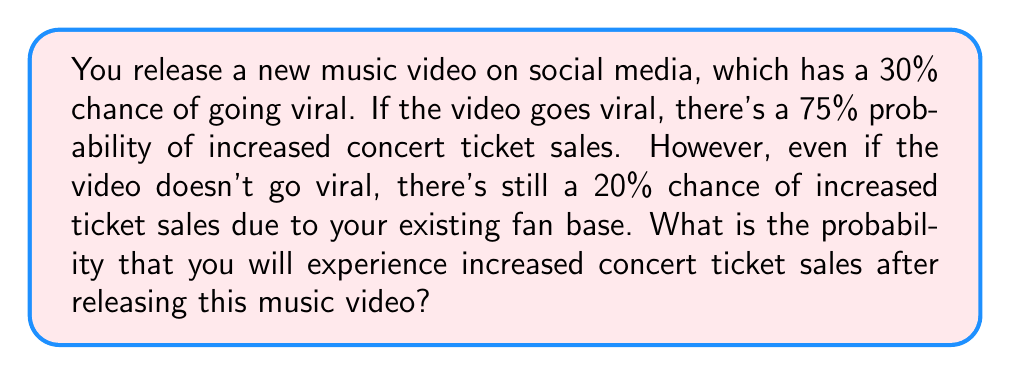Give your solution to this math problem. Let's approach this step-by-step using the law of total probability:

1) Define events:
   V: Video goes viral
   S: Increased ticket sales

2) Given probabilities:
   P(V) = 0.30 (30% chance of going viral)
   P(S|V) = 0.75 (75% chance of increased sales if viral)
   P(S|not V) = 0.20 (20% chance of increased sales if not viral)

3) Apply the law of total probability:
   P(S) = P(S|V) * P(V) + P(S|not V) * P(not V)

4) Calculate P(not V):
   P(not V) = 1 - P(V) = 1 - 0.30 = 0.70

5) Substitute values into the formula:
   P(S) = 0.75 * 0.30 + 0.20 * 0.70

6) Compute:
   P(S) = 0.225 + 0.14 = 0.365

Therefore, the probability of increased concert ticket sales is 0.365 or 36.5%.
Answer: 0.365 